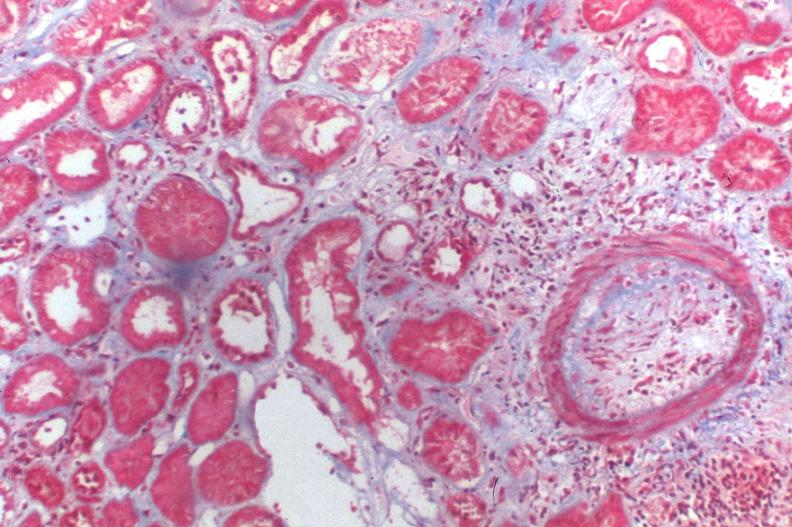where is this?
Answer the question using a single word or phrase. Urinary 